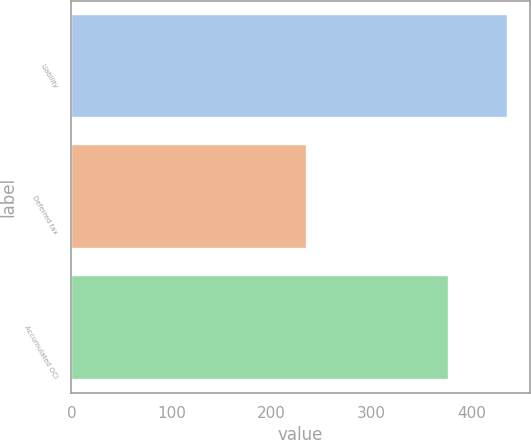Convert chart. <chart><loc_0><loc_0><loc_500><loc_500><bar_chart><fcel>Liability<fcel>Deferred tax<fcel>Accumulated OCI<nl><fcel>436<fcel>235<fcel>377<nl></chart> 